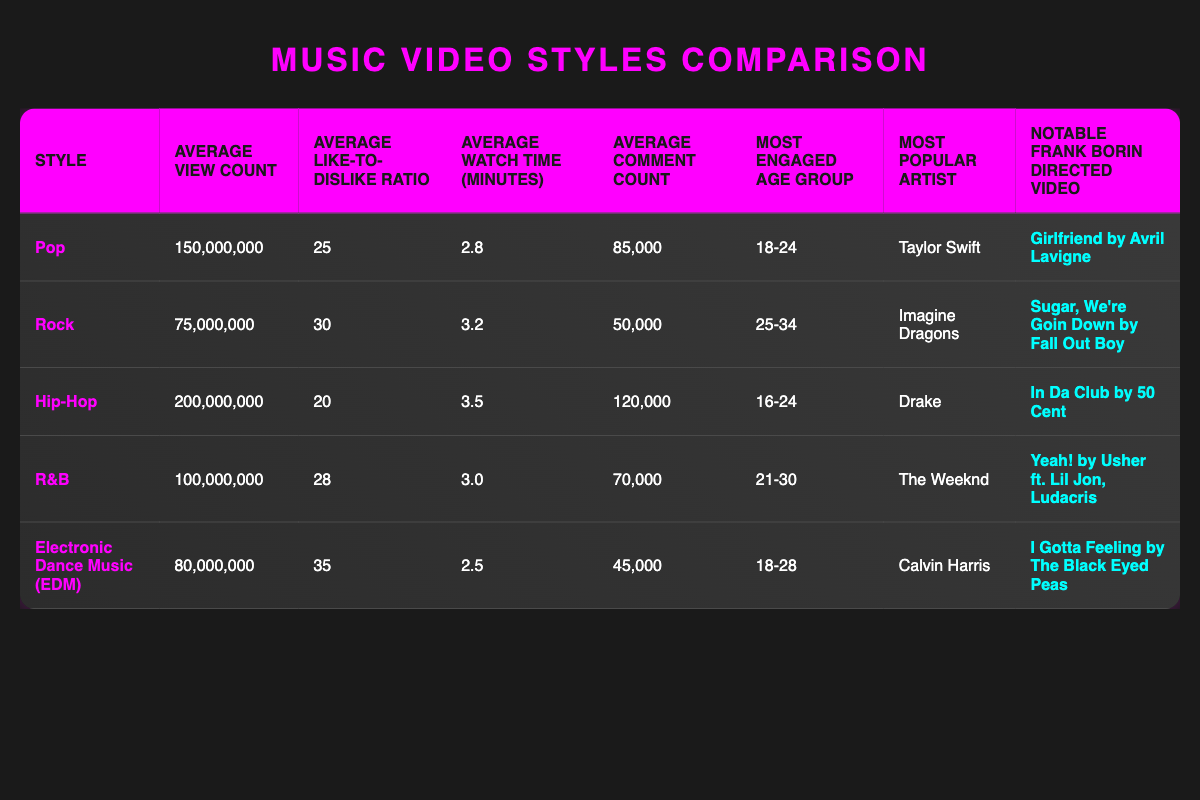What is the average view count for pop music videos? The table states that the average view count for pop music videos is 150,000,000.
Answer: 150,000,000 Which music video style has the highest average watch time? From the table, hip-hop music videos have the highest average watch time at 3.5 minutes, whereas rock and other styles have lower values.
Answer: Hip-Hop Is the like-to-dislike ratio for electronic dance music greater than that for hip-hop? The table shows the like-to-dislike ratio for EDM is 35 while for hip-hop it is 20, so EDM's ratio is indeed greater.
Answer: Yes How many more comments do hip-hop videos receive on average compared to rock videos? Looking at the table, hip-hop videos have an average comment count of 120,000, while rock videos have 50,000. The difference is 120,000 - 50,000 = 70,000.
Answer: 70,000 Which artist has the highest average view count and what is that count? The table indicates that hip-hop videos featuring Drake have the highest average view count of 200,000,000.
Answer: Drake, 200,000,000 What is the average like-to-dislike ratio for R&B music videos? According to the data in the table, the average like-to-dislike ratio for R&B is 28.
Answer: 28 Is the most engaged age group for pop music videos older than that for hip-hop music videos? The most engaged age group for pop music videos is 18-24 and for hip-hop, it is 16-24. Since 18-24 is older than 16-24, the statement is true.
Answer: Yes Which music video style has the most engaged age group of 25-34? Referring to the table, rock music videos have the most engaged age group of 25-34.
Answer: Rock What is the average view count for all styles combined? To find the average view count across all styles, add the view counts (150,000,000 + 75,000,000 + 200,000,000 + 100,000,000 + 80,000,000 = 605,000,000) and divide by 5 (the number of styles), giving us an average of 121,000,000.
Answer: 121,000,000 